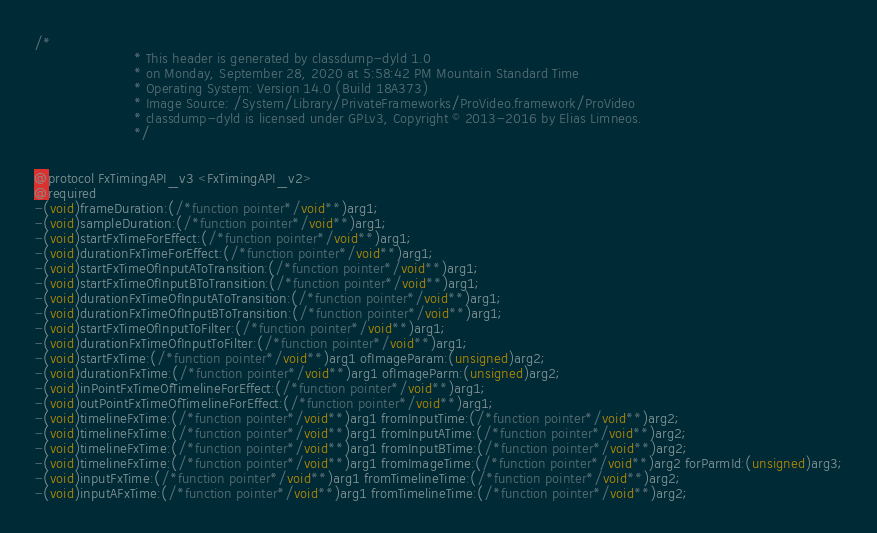<code> <loc_0><loc_0><loc_500><loc_500><_C_>/*
                       * This header is generated by classdump-dyld 1.0
                       * on Monday, September 28, 2020 at 5:58:42 PM Mountain Standard Time
                       * Operating System: Version 14.0 (Build 18A373)
                       * Image Source: /System/Library/PrivateFrameworks/ProVideo.framework/ProVideo
                       * classdump-dyld is licensed under GPLv3, Copyright © 2013-2016 by Elias Limneos.
                       */


@protocol FxTimingAPI_v3 <FxTimingAPI_v2>
@required
-(void)frameDuration:(/*function pointer*/void**)arg1;
-(void)sampleDuration:(/*function pointer*/void**)arg1;
-(void)startFxTimeForEffect:(/*function pointer*/void**)arg1;
-(void)durationFxTimeForEffect:(/*function pointer*/void**)arg1;
-(void)startFxTimeOfInputAToTransition:(/*function pointer*/void**)arg1;
-(void)startFxTimeOfInputBToTransition:(/*function pointer*/void**)arg1;
-(void)durationFxTimeOfInputAToTransition:(/*function pointer*/void**)arg1;
-(void)durationFxTimeOfInputBToTransition:(/*function pointer*/void**)arg1;
-(void)startFxTimeOfInputToFilter:(/*function pointer*/void**)arg1;
-(void)durationFxTimeOfInputToFilter:(/*function pointer*/void**)arg1;
-(void)startFxTime:(/*function pointer*/void**)arg1 ofImageParam:(unsigned)arg2;
-(void)durationFxTime:(/*function pointer*/void**)arg1 ofImageParm:(unsigned)arg2;
-(void)inPointFxTimeOfTimelineForEffect:(/*function pointer*/void**)arg1;
-(void)outPointFxTimeOfTimelineForEffect:(/*function pointer*/void**)arg1;
-(void)timelineFxTime:(/*function pointer*/void**)arg1 fromInputTime:(/*function pointer*/void**)arg2;
-(void)timelineFxTime:(/*function pointer*/void**)arg1 fromInputATime:(/*function pointer*/void**)arg2;
-(void)timelineFxTime:(/*function pointer*/void**)arg1 fromInputBTime:(/*function pointer*/void**)arg2;
-(void)timelineFxTime:(/*function pointer*/void**)arg1 fromImageTime:(/*function pointer*/void**)arg2 forParmId:(unsigned)arg3;
-(void)inputFxTime:(/*function pointer*/void**)arg1 fromTimelineTime:(/*function pointer*/void**)arg2;
-(void)inputAFxTime:(/*function pointer*/void**)arg1 fromTimelineTime:(/*function pointer*/void**)arg2;</code> 